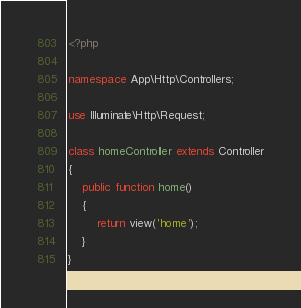Convert code to text. <code><loc_0><loc_0><loc_500><loc_500><_PHP_><?php

namespace App\Http\Controllers;

use Illuminate\Http\Request;

class homeController extends Controller
{
    public function home()
    {
        return view('home');
    }
}
</code> 